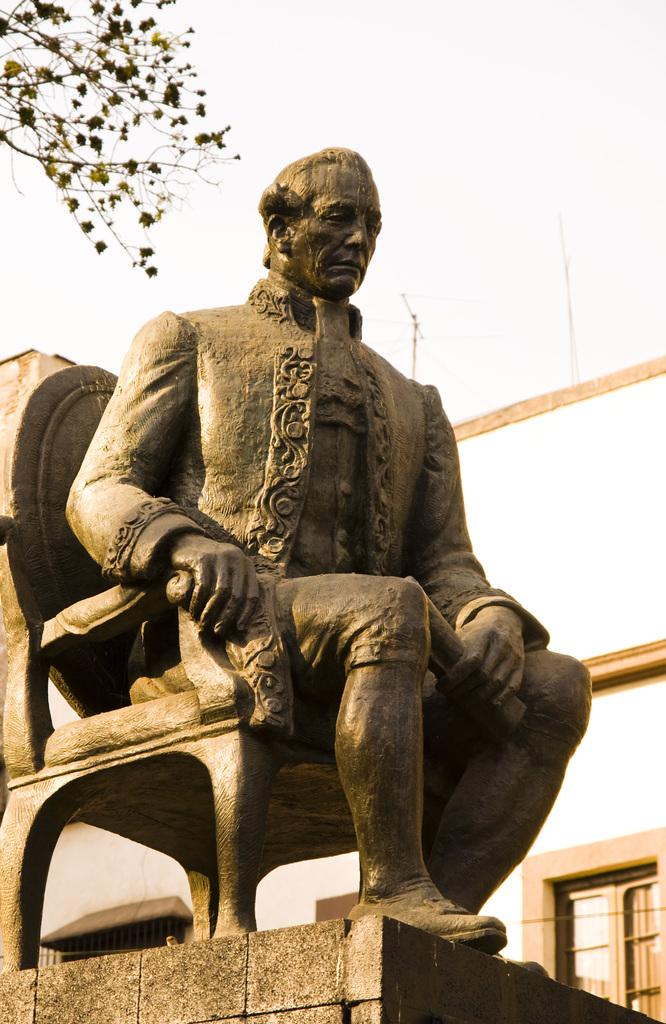What is the main subject in the center of the image? There is a statue in the center of the image. What can be seen in the background of the image? There is a building and a tree in the background of the image. What is visible in the sky in the image? The sky is visible in the background of the image. What type of texture can be seen on the cook's apron in the image? There is no cook or apron present in the image; it features a statue, building, tree, and sky. 